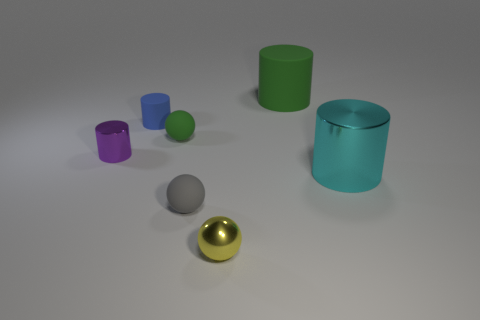Add 2 green rubber objects. How many objects exist? 9 Subtract all spheres. How many objects are left? 4 Add 2 tiny green things. How many tiny green things exist? 3 Subtract 1 purple cylinders. How many objects are left? 6 Subtract all matte cylinders. Subtract all purple metal cylinders. How many objects are left? 4 Add 6 big matte cylinders. How many big matte cylinders are left? 7 